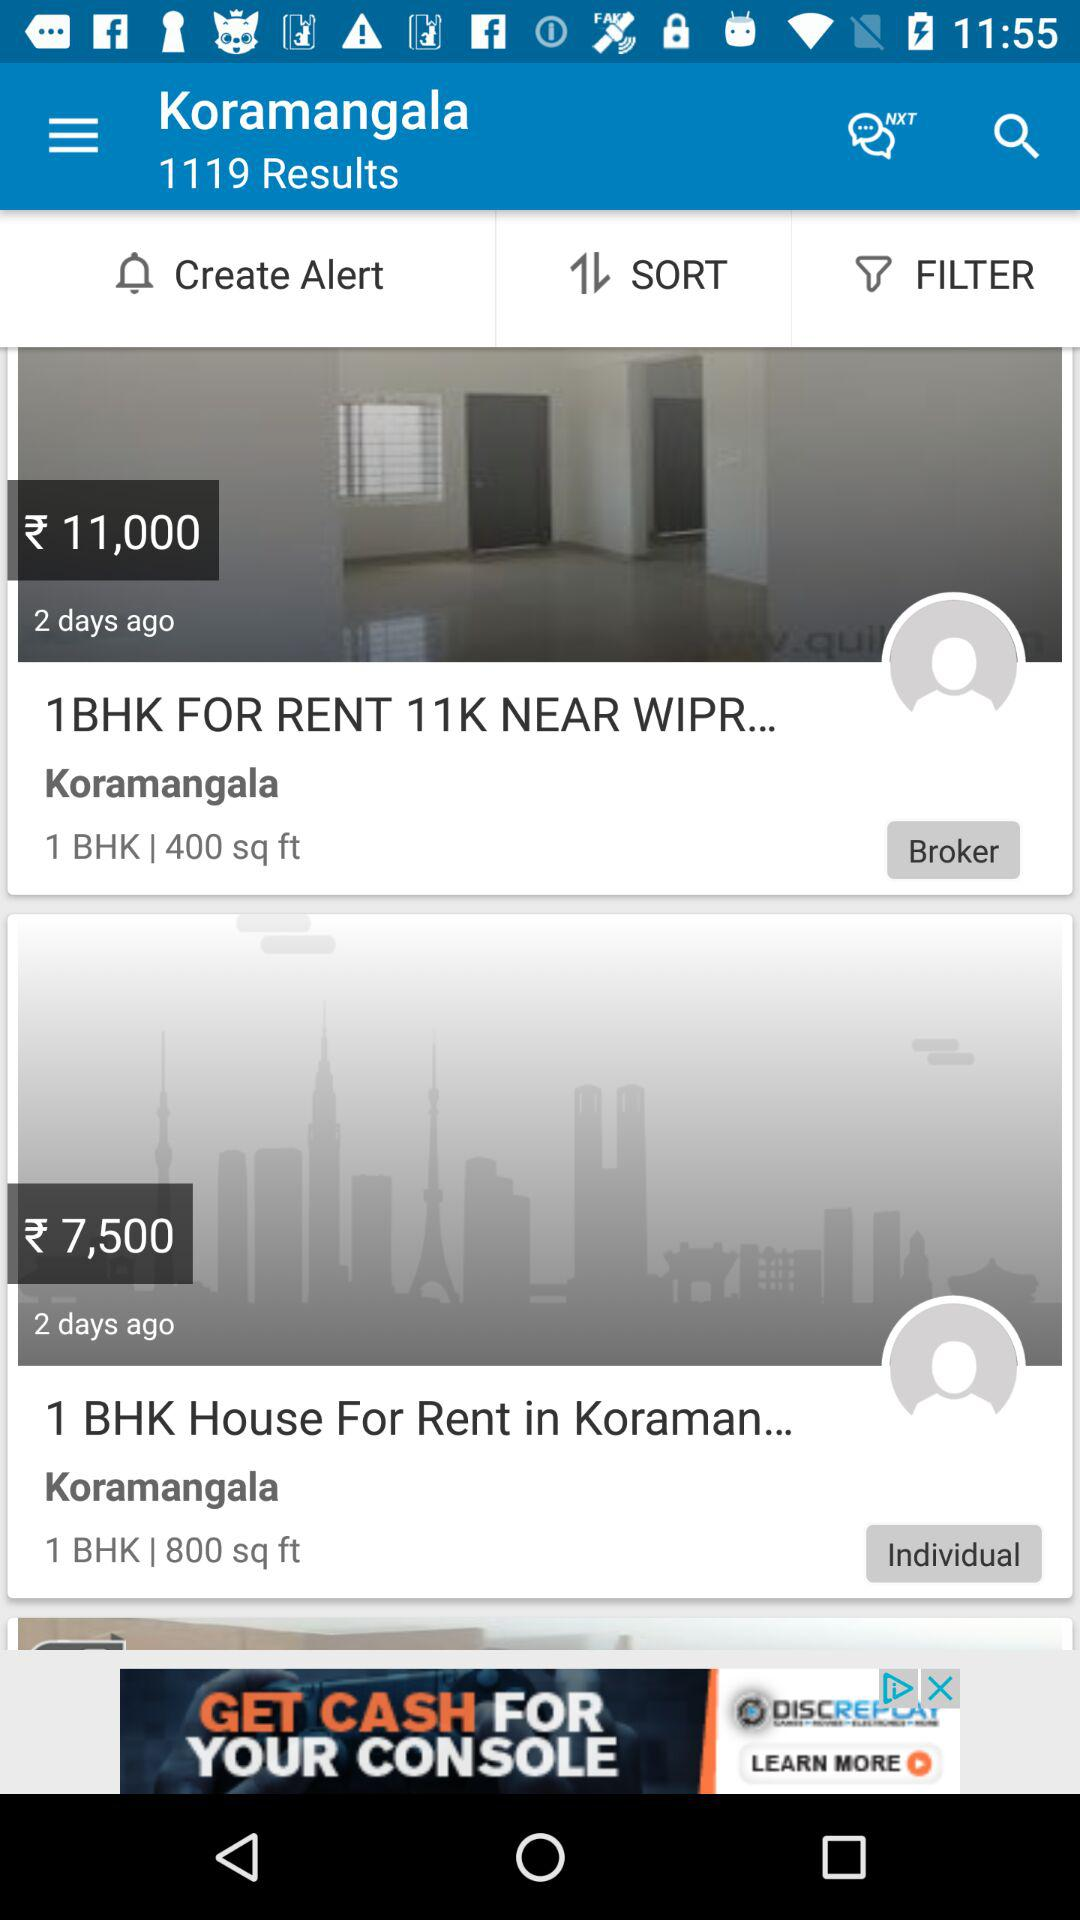How many days ago was the flat updated? The flat was updated 2 days ago. 